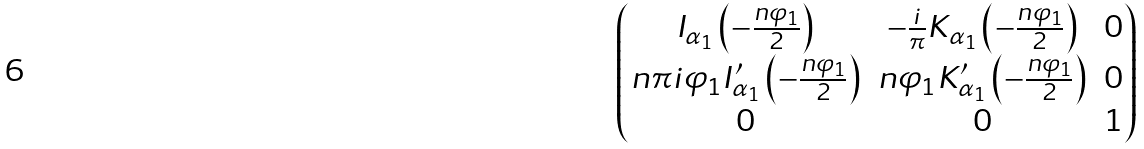<formula> <loc_0><loc_0><loc_500><loc_500>\begin{pmatrix} I _ { \alpha _ { 1 } } \left ( - \frac { n \varphi _ { 1 } } { 2 } \right ) & - \frac { i } { \pi } K _ { \alpha _ { 1 } } \left ( - \frac { n \varphi _ { 1 } } { 2 } \right ) & 0 \\ n \pi i \varphi _ { 1 } I _ { \alpha _ { 1 } } ^ { \prime } \left ( - \frac { n \varphi _ { 1 } } { 2 } \right ) & n \varphi _ { 1 } K _ { \alpha _ { 1 } } ^ { \prime } \left ( - \frac { n \varphi _ { 1 } } { 2 } \right ) & 0 \\ 0 & 0 & 1 \end{pmatrix}</formula> 